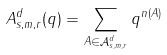Convert formula to latex. <formula><loc_0><loc_0><loc_500><loc_500>A _ { s , m , r } ^ { d } ( q ) = \sum _ { A \in \mathcal { A } _ { s , m , r } ^ { d } } q ^ { n ( A ) }</formula> 